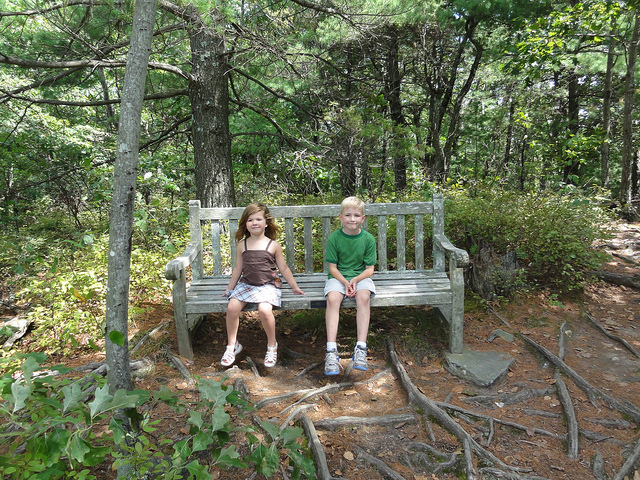What are some activities you might do in this setting? In a setting like this, you might enjoy activities such as hiking through the forest, bird watching, having a leisurely picnic, or simply sitting and enjoying the serene natural environment. What wildlife could you see around here? In this forested area, you might see a variety of wildlife including birds like woodpeckers and robins, small mammals such as squirrels and chipmunks, insects like butterflies and beetles, and if you're lucky, maybe even a deer passing through. 